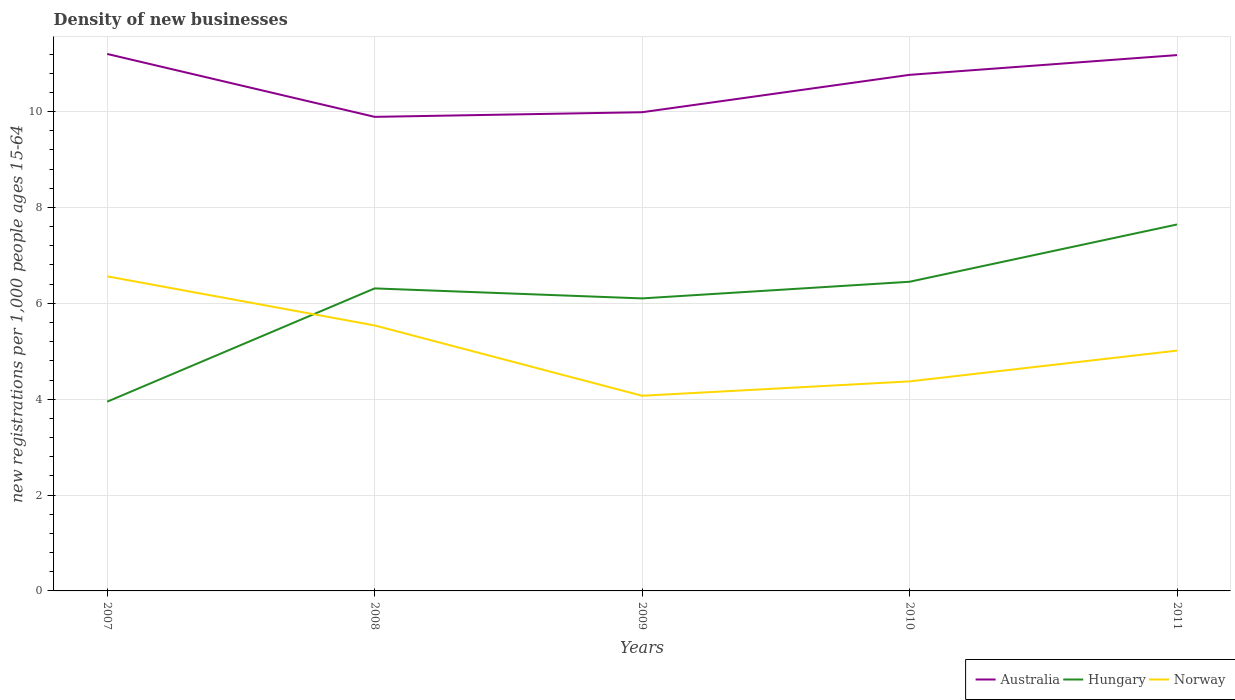How many different coloured lines are there?
Offer a very short reply. 3. Is the number of lines equal to the number of legend labels?
Keep it short and to the point. Yes. Across all years, what is the maximum number of new registrations in Australia?
Ensure brevity in your answer.  9.89. In which year was the number of new registrations in Norway maximum?
Your response must be concise. 2009. What is the total number of new registrations in Norway in the graph?
Provide a succinct answer. -0.3. What is the difference between the highest and the second highest number of new registrations in Hungary?
Ensure brevity in your answer.  3.7. What is the difference between the highest and the lowest number of new registrations in Hungary?
Offer a terse response. 4. How many lines are there?
Make the answer very short. 3. What is the difference between two consecutive major ticks on the Y-axis?
Your answer should be very brief. 2. Are the values on the major ticks of Y-axis written in scientific E-notation?
Provide a succinct answer. No. Does the graph contain any zero values?
Your response must be concise. No. Does the graph contain grids?
Your answer should be very brief. Yes. Where does the legend appear in the graph?
Your answer should be compact. Bottom right. How many legend labels are there?
Make the answer very short. 3. What is the title of the graph?
Provide a short and direct response. Density of new businesses. What is the label or title of the X-axis?
Provide a succinct answer. Years. What is the label or title of the Y-axis?
Keep it short and to the point. New registrations per 1,0 people ages 15-64. What is the new registrations per 1,000 people ages 15-64 in Australia in 2007?
Ensure brevity in your answer.  11.2. What is the new registrations per 1,000 people ages 15-64 in Hungary in 2007?
Make the answer very short. 3.95. What is the new registrations per 1,000 people ages 15-64 in Norway in 2007?
Your answer should be compact. 6.56. What is the new registrations per 1,000 people ages 15-64 in Australia in 2008?
Ensure brevity in your answer.  9.89. What is the new registrations per 1,000 people ages 15-64 of Hungary in 2008?
Provide a succinct answer. 6.31. What is the new registrations per 1,000 people ages 15-64 of Norway in 2008?
Provide a succinct answer. 5.54. What is the new registrations per 1,000 people ages 15-64 in Australia in 2009?
Your answer should be compact. 9.99. What is the new registrations per 1,000 people ages 15-64 of Hungary in 2009?
Keep it short and to the point. 6.1. What is the new registrations per 1,000 people ages 15-64 of Norway in 2009?
Provide a short and direct response. 4.07. What is the new registrations per 1,000 people ages 15-64 of Australia in 2010?
Ensure brevity in your answer.  10.77. What is the new registrations per 1,000 people ages 15-64 in Hungary in 2010?
Make the answer very short. 6.45. What is the new registrations per 1,000 people ages 15-64 of Norway in 2010?
Provide a succinct answer. 4.37. What is the new registrations per 1,000 people ages 15-64 in Australia in 2011?
Offer a very short reply. 11.18. What is the new registrations per 1,000 people ages 15-64 in Hungary in 2011?
Provide a short and direct response. 7.64. What is the new registrations per 1,000 people ages 15-64 of Norway in 2011?
Your response must be concise. 5.01. Across all years, what is the maximum new registrations per 1,000 people ages 15-64 of Australia?
Provide a succinct answer. 11.2. Across all years, what is the maximum new registrations per 1,000 people ages 15-64 in Hungary?
Provide a short and direct response. 7.64. Across all years, what is the maximum new registrations per 1,000 people ages 15-64 in Norway?
Your answer should be very brief. 6.56. Across all years, what is the minimum new registrations per 1,000 people ages 15-64 of Australia?
Offer a terse response. 9.89. Across all years, what is the minimum new registrations per 1,000 people ages 15-64 in Hungary?
Your answer should be very brief. 3.95. Across all years, what is the minimum new registrations per 1,000 people ages 15-64 of Norway?
Your answer should be compact. 4.07. What is the total new registrations per 1,000 people ages 15-64 of Australia in the graph?
Offer a very short reply. 53.02. What is the total new registrations per 1,000 people ages 15-64 of Hungary in the graph?
Provide a succinct answer. 30.46. What is the total new registrations per 1,000 people ages 15-64 in Norway in the graph?
Keep it short and to the point. 25.56. What is the difference between the new registrations per 1,000 people ages 15-64 of Australia in 2007 and that in 2008?
Provide a short and direct response. 1.31. What is the difference between the new registrations per 1,000 people ages 15-64 in Hungary in 2007 and that in 2008?
Offer a terse response. -2.36. What is the difference between the new registrations per 1,000 people ages 15-64 of Norway in 2007 and that in 2008?
Your response must be concise. 1.02. What is the difference between the new registrations per 1,000 people ages 15-64 in Australia in 2007 and that in 2009?
Ensure brevity in your answer.  1.22. What is the difference between the new registrations per 1,000 people ages 15-64 of Hungary in 2007 and that in 2009?
Keep it short and to the point. -2.15. What is the difference between the new registrations per 1,000 people ages 15-64 of Norway in 2007 and that in 2009?
Offer a terse response. 2.49. What is the difference between the new registrations per 1,000 people ages 15-64 in Australia in 2007 and that in 2010?
Your answer should be compact. 0.44. What is the difference between the new registrations per 1,000 people ages 15-64 in Hungary in 2007 and that in 2010?
Offer a terse response. -2.5. What is the difference between the new registrations per 1,000 people ages 15-64 in Norway in 2007 and that in 2010?
Give a very brief answer. 2.19. What is the difference between the new registrations per 1,000 people ages 15-64 of Australia in 2007 and that in 2011?
Your answer should be compact. 0.02. What is the difference between the new registrations per 1,000 people ages 15-64 of Hungary in 2007 and that in 2011?
Keep it short and to the point. -3.7. What is the difference between the new registrations per 1,000 people ages 15-64 in Norway in 2007 and that in 2011?
Give a very brief answer. 1.55. What is the difference between the new registrations per 1,000 people ages 15-64 of Australia in 2008 and that in 2009?
Your answer should be compact. -0.1. What is the difference between the new registrations per 1,000 people ages 15-64 in Hungary in 2008 and that in 2009?
Offer a very short reply. 0.21. What is the difference between the new registrations per 1,000 people ages 15-64 in Norway in 2008 and that in 2009?
Offer a very short reply. 1.47. What is the difference between the new registrations per 1,000 people ages 15-64 in Australia in 2008 and that in 2010?
Your response must be concise. -0.88. What is the difference between the new registrations per 1,000 people ages 15-64 in Hungary in 2008 and that in 2010?
Make the answer very short. -0.14. What is the difference between the new registrations per 1,000 people ages 15-64 in Norway in 2008 and that in 2010?
Offer a very short reply. 1.17. What is the difference between the new registrations per 1,000 people ages 15-64 in Australia in 2008 and that in 2011?
Ensure brevity in your answer.  -1.29. What is the difference between the new registrations per 1,000 people ages 15-64 of Hungary in 2008 and that in 2011?
Ensure brevity in your answer.  -1.33. What is the difference between the new registrations per 1,000 people ages 15-64 of Norway in 2008 and that in 2011?
Provide a short and direct response. 0.53. What is the difference between the new registrations per 1,000 people ages 15-64 in Australia in 2009 and that in 2010?
Make the answer very short. -0.78. What is the difference between the new registrations per 1,000 people ages 15-64 of Hungary in 2009 and that in 2010?
Give a very brief answer. -0.35. What is the difference between the new registrations per 1,000 people ages 15-64 in Norway in 2009 and that in 2010?
Your answer should be very brief. -0.3. What is the difference between the new registrations per 1,000 people ages 15-64 of Australia in 2009 and that in 2011?
Your answer should be very brief. -1.19. What is the difference between the new registrations per 1,000 people ages 15-64 in Hungary in 2009 and that in 2011?
Ensure brevity in your answer.  -1.54. What is the difference between the new registrations per 1,000 people ages 15-64 of Norway in 2009 and that in 2011?
Your answer should be compact. -0.94. What is the difference between the new registrations per 1,000 people ages 15-64 in Australia in 2010 and that in 2011?
Ensure brevity in your answer.  -0.41. What is the difference between the new registrations per 1,000 people ages 15-64 of Hungary in 2010 and that in 2011?
Make the answer very short. -1.19. What is the difference between the new registrations per 1,000 people ages 15-64 in Norway in 2010 and that in 2011?
Give a very brief answer. -0.64. What is the difference between the new registrations per 1,000 people ages 15-64 of Australia in 2007 and the new registrations per 1,000 people ages 15-64 of Hungary in 2008?
Keep it short and to the point. 4.89. What is the difference between the new registrations per 1,000 people ages 15-64 in Australia in 2007 and the new registrations per 1,000 people ages 15-64 in Norway in 2008?
Your answer should be very brief. 5.66. What is the difference between the new registrations per 1,000 people ages 15-64 in Hungary in 2007 and the new registrations per 1,000 people ages 15-64 in Norway in 2008?
Your answer should be compact. -1.59. What is the difference between the new registrations per 1,000 people ages 15-64 of Australia in 2007 and the new registrations per 1,000 people ages 15-64 of Hungary in 2009?
Offer a very short reply. 5.1. What is the difference between the new registrations per 1,000 people ages 15-64 of Australia in 2007 and the new registrations per 1,000 people ages 15-64 of Norway in 2009?
Your answer should be compact. 7.13. What is the difference between the new registrations per 1,000 people ages 15-64 of Hungary in 2007 and the new registrations per 1,000 people ages 15-64 of Norway in 2009?
Offer a terse response. -0.12. What is the difference between the new registrations per 1,000 people ages 15-64 in Australia in 2007 and the new registrations per 1,000 people ages 15-64 in Hungary in 2010?
Ensure brevity in your answer.  4.75. What is the difference between the new registrations per 1,000 people ages 15-64 in Australia in 2007 and the new registrations per 1,000 people ages 15-64 in Norway in 2010?
Offer a very short reply. 6.83. What is the difference between the new registrations per 1,000 people ages 15-64 in Hungary in 2007 and the new registrations per 1,000 people ages 15-64 in Norway in 2010?
Keep it short and to the point. -0.42. What is the difference between the new registrations per 1,000 people ages 15-64 of Australia in 2007 and the new registrations per 1,000 people ages 15-64 of Hungary in 2011?
Your answer should be very brief. 3.56. What is the difference between the new registrations per 1,000 people ages 15-64 of Australia in 2007 and the new registrations per 1,000 people ages 15-64 of Norway in 2011?
Give a very brief answer. 6.19. What is the difference between the new registrations per 1,000 people ages 15-64 in Hungary in 2007 and the new registrations per 1,000 people ages 15-64 in Norway in 2011?
Make the answer very short. -1.07. What is the difference between the new registrations per 1,000 people ages 15-64 in Australia in 2008 and the new registrations per 1,000 people ages 15-64 in Hungary in 2009?
Make the answer very short. 3.79. What is the difference between the new registrations per 1,000 people ages 15-64 in Australia in 2008 and the new registrations per 1,000 people ages 15-64 in Norway in 2009?
Ensure brevity in your answer.  5.82. What is the difference between the new registrations per 1,000 people ages 15-64 of Hungary in 2008 and the new registrations per 1,000 people ages 15-64 of Norway in 2009?
Make the answer very short. 2.24. What is the difference between the new registrations per 1,000 people ages 15-64 in Australia in 2008 and the new registrations per 1,000 people ages 15-64 in Hungary in 2010?
Make the answer very short. 3.44. What is the difference between the new registrations per 1,000 people ages 15-64 in Australia in 2008 and the new registrations per 1,000 people ages 15-64 in Norway in 2010?
Your answer should be compact. 5.52. What is the difference between the new registrations per 1,000 people ages 15-64 of Hungary in 2008 and the new registrations per 1,000 people ages 15-64 of Norway in 2010?
Make the answer very short. 1.94. What is the difference between the new registrations per 1,000 people ages 15-64 of Australia in 2008 and the new registrations per 1,000 people ages 15-64 of Hungary in 2011?
Offer a very short reply. 2.25. What is the difference between the new registrations per 1,000 people ages 15-64 in Australia in 2008 and the new registrations per 1,000 people ages 15-64 in Norway in 2011?
Offer a very short reply. 4.88. What is the difference between the new registrations per 1,000 people ages 15-64 of Hungary in 2008 and the new registrations per 1,000 people ages 15-64 of Norway in 2011?
Your answer should be very brief. 1.3. What is the difference between the new registrations per 1,000 people ages 15-64 of Australia in 2009 and the new registrations per 1,000 people ages 15-64 of Hungary in 2010?
Your answer should be very brief. 3.54. What is the difference between the new registrations per 1,000 people ages 15-64 in Australia in 2009 and the new registrations per 1,000 people ages 15-64 in Norway in 2010?
Provide a short and direct response. 5.62. What is the difference between the new registrations per 1,000 people ages 15-64 in Hungary in 2009 and the new registrations per 1,000 people ages 15-64 in Norway in 2010?
Provide a short and direct response. 1.73. What is the difference between the new registrations per 1,000 people ages 15-64 in Australia in 2009 and the new registrations per 1,000 people ages 15-64 in Hungary in 2011?
Make the answer very short. 2.34. What is the difference between the new registrations per 1,000 people ages 15-64 of Australia in 2009 and the new registrations per 1,000 people ages 15-64 of Norway in 2011?
Offer a terse response. 4.97. What is the difference between the new registrations per 1,000 people ages 15-64 in Hungary in 2009 and the new registrations per 1,000 people ages 15-64 in Norway in 2011?
Give a very brief answer. 1.09. What is the difference between the new registrations per 1,000 people ages 15-64 in Australia in 2010 and the new registrations per 1,000 people ages 15-64 in Hungary in 2011?
Make the answer very short. 3.12. What is the difference between the new registrations per 1,000 people ages 15-64 of Australia in 2010 and the new registrations per 1,000 people ages 15-64 of Norway in 2011?
Make the answer very short. 5.75. What is the difference between the new registrations per 1,000 people ages 15-64 in Hungary in 2010 and the new registrations per 1,000 people ages 15-64 in Norway in 2011?
Ensure brevity in your answer.  1.44. What is the average new registrations per 1,000 people ages 15-64 in Australia per year?
Offer a very short reply. 10.6. What is the average new registrations per 1,000 people ages 15-64 in Hungary per year?
Make the answer very short. 6.09. What is the average new registrations per 1,000 people ages 15-64 in Norway per year?
Your answer should be very brief. 5.11. In the year 2007, what is the difference between the new registrations per 1,000 people ages 15-64 in Australia and new registrations per 1,000 people ages 15-64 in Hungary?
Ensure brevity in your answer.  7.25. In the year 2007, what is the difference between the new registrations per 1,000 people ages 15-64 of Australia and new registrations per 1,000 people ages 15-64 of Norway?
Your answer should be very brief. 4.64. In the year 2007, what is the difference between the new registrations per 1,000 people ages 15-64 of Hungary and new registrations per 1,000 people ages 15-64 of Norway?
Your answer should be very brief. -2.61. In the year 2008, what is the difference between the new registrations per 1,000 people ages 15-64 of Australia and new registrations per 1,000 people ages 15-64 of Hungary?
Provide a short and direct response. 3.58. In the year 2008, what is the difference between the new registrations per 1,000 people ages 15-64 of Australia and new registrations per 1,000 people ages 15-64 of Norway?
Give a very brief answer. 4.35. In the year 2008, what is the difference between the new registrations per 1,000 people ages 15-64 of Hungary and new registrations per 1,000 people ages 15-64 of Norway?
Offer a very short reply. 0.77. In the year 2009, what is the difference between the new registrations per 1,000 people ages 15-64 in Australia and new registrations per 1,000 people ages 15-64 in Hungary?
Offer a very short reply. 3.88. In the year 2009, what is the difference between the new registrations per 1,000 people ages 15-64 in Australia and new registrations per 1,000 people ages 15-64 in Norway?
Provide a succinct answer. 5.92. In the year 2009, what is the difference between the new registrations per 1,000 people ages 15-64 in Hungary and new registrations per 1,000 people ages 15-64 in Norway?
Offer a terse response. 2.03. In the year 2010, what is the difference between the new registrations per 1,000 people ages 15-64 in Australia and new registrations per 1,000 people ages 15-64 in Hungary?
Make the answer very short. 4.32. In the year 2010, what is the difference between the new registrations per 1,000 people ages 15-64 of Australia and new registrations per 1,000 people ages 15-64 of Norway?
Give a very brief answer. 6.4. In the year 2010, what is the difference between the new registrations per 1,000 people ages 15-64 in Hungary and new registrations per 1,000 people ages 15-64 in Norway?
Give a very brief answer. 2.08. In the year 2011, what is the difference between the new registrations per 1,000 people ages 15-64 in Australia and new registrations per 1,000 people ages 15-64 in Hungary?
Your answer should be very brief. 3.53. In the year 2011, what is the difference between the new registrations per 1,000 people ages 15-64 of Australia and new registrations per 1,000 people ages 15-64 of Norway?
Ensure brevity in your answer.  6.17. In the year 2011, what is the difference between the new registrations per 1,000 people ages 15-64 in Hungary and new registrations per 1,000 people ages 15-64 in Norway?
Give a very brief answer. 2.63. What is the ratio of the new registrations per 1,000 people ages 15-64 in Australia in 2007 to that in 2008?
Ensure brevity in your answer.  1.13. What is the ratio of the new registrations per 1,000 people ages 15-64 in Hungary in 2007 to that in 2008?
Offer a very short reply. 0.63. What is the ratio of the new registrations per 1,000 people ages 15-64 of Norway in 2007 to that in 2008?
Offer a very short reply. 1.18. What is the ratio of the new registrations per 1,000 people ages 15-64 in Australia in 2007 to that in 2009?
Offer a very short reply. 1.12. What is the ratio of the new registrations per 1,000 people ages 15-64 in Hungary in 2007 to that in 2009?
Provide a succinct answer. 0.65. What is the ratio of the new registrations per 1,000 people ages 15-64 in Norway in 2007 to that in 2009?
Offer a very short reply. 1.61. What is the ratio of the new registrations per 1,000 people ages 15-64 of Australia in 2007 to that in 2010?
Provide a short and direct response. 1.04. What is the ratio of the new registrations per 1,000 people ages 15-64 in Hungary in 2007 to that in 2010?
Your answer should be compact. 0.61. What is the ratio of the new registrations per 1,000 people ages 15-64 of Norway in 2007 to that in 2010?
Your response must be concise. 1.5. What is the ratio of the new registrations per 1,000 people ages 15-64 of Australia in 2007 to that in 2011?
Make the answer very short. 1. What is the ratio of the new registrations per 1,000 people ages 15-64 in Hungary in 2007 to that in 2011?
Provide a succinct answer. 0.52. What is the ratio of the new registrations per 1,000 people ages 15-64 in Norway in 2007 to that in 2011?
Make the answer very short. 1.31. What is the ratio of the new registrations per 1,000 people ages 15-64 of Australia in 2008 to that in 2009?
Offer a terse response. 0.99. What is the ratio of the new registrations per 1,000 people ages 15-64 in Hungary in 2008 to that in 2009?
Ensure brevity in your answer.  1.03. What is the ratio of the new registrations per 1,000 people ages 15-64 in Norway in 2008 to that in 2009?
Offer a very short reply. 1.36. What is the ratio of the new registrations per 1,000 people ages 15-64 of Australia in 2008 to that in 2010?
Your answer should be compact. 0.92. What is the ratio of the new registrations per 1,000 people ages 15-64 of Hungary in 2008 to that in 2010?
Give a very brief answer. 0.98. What is the ratio of the new registrations per 1,000 people ages 15-64 in Norway in 2008 to that in 2010?
Offer a terse response. 1.27. What is the ratio of the new registrations per 1,000 people ages 15-64 in Australia in 2008 to that in 2011?
Provide a succinct answer. 0.88. What is the ratio of the new registrations per 1,000 people ages 15-64 of Hungary in 2008 to that in 2011?
Offer a very short reply. 0.83. What is the ratio of the new registrations per 1,000 people ages 15-64 of Norway in 2008 to that in 2011?
Offer a very short reply. 1.1. What is the ratio of the new registrations per 1,000 people ages 15-64 in Australia in 2009 to that in 2010?
Give a very brief answer. 0.93. What is the ratio of the new registrations per 1,000 people ages 15-64 in Hungary in 2009 to that in 2010?
Offer a terse response. 0.95. What is the ratio of the new registrations per 1,000 people ages 15-64 of Norway in 2009 to that in 2010?
Your answer should be very brief. 0.93. What is the ratio of the new registrations per 1,000 people ages 15-64 of Australia in 2009 to that in 2011?
Give a very brief answer. 0.89. What is the ratio of the new registrations per 1,000 people ages 15-64 in Hungary in 2009 to that in 2011?
Provide a short and direct response. 0.8. What is the ratio of the new registrations per 1,000 people ages 15-64 in Norway in 2009 to that in 2011?
Ensure brevity in your answer.  0.81. What is the ratio of the new registrations per 1,000 people ages 15-64 of Australia in 2010 to that in 2011?
Offer a very short reply. 0.96. What is the ratio of the new registrations per 1,000 people ages 15-64 in Hungary in 2010 to that in 2011?
Your answer should be compact. 0.84. What is the ratio of the new registrations per 1,000 people ages 15-64 in Norway in 2010 to that in 2011?
Provide a short and direct response. 0.87. What is the difference between the highest and the second highest new registrations per 1,000 people ages 15-64 in Australia?
Offer a very short reply. 0.02. What is the difference between the highest and the second highest new registrations per 1,000 people ages 15-64 in Hungary?
Provide a short and direct response. 1.19. What is the difference between the highest and the second highest new registrations per 1,000 people ages 15-64 of Norway?
Your answer should be very brief. 1.02. What is the difference between the highest and the lowest new registrations per 1,000 people ages 15-64 in Australia?
Provide a succinct answer. 1.31. What is the difference between the highest and the lowest new registrations per 1,000 people ages 15-64 of Hungary?
Offer a terse response. 3.7. What is the difference between the highest and the lowest new registrations per 1,000 people ages 15-64 of Norway?
Give a very brief answer. 2.49. 